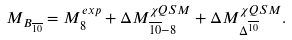Convert formula to latex. <formula><loc_0><loc_0><loc_500><loc_500>M _ { B _ { \overline { 1 0 } } } = M _ { 8 } ^ { e x p } + \Delta M _ { \overline { 1 0 } - 8 } ^ { \chi Q S M } + \Delta M _ { \Delta ^ { \overline { 1 0 } } } ^ { \chi Q S M } .</formula> 